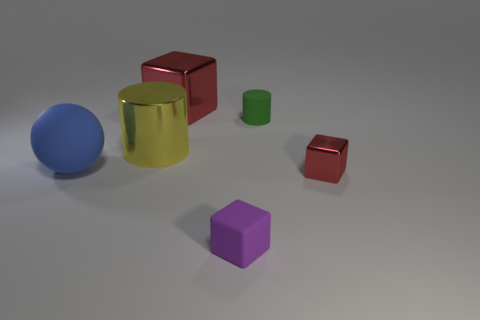Subtract all tiny purple blocks. How many blocks are left? 2 Subtract all purple blocks. How many blocks are left? 2 Add 2 tiny brown objects. How many objects exist? 8 Subtract all cylinders. How many objects are left? 4 Subtract all gray cylinders. How many red cubes are left? 2 Subtract 2 cylinders. How many cylinders are left? 0 Subtract all brown cylinders. Subtract all yellow cubes. How many cylinders are left? 2 Subtract all large yellow metal things. Subtract all small shiny objects. How many objects are left? 4 Add 2 matte spheres. How many matte spheres are left? 3 Add 6 large gray rubber cylinders. How many large gray rubber cylinders exist? 6 